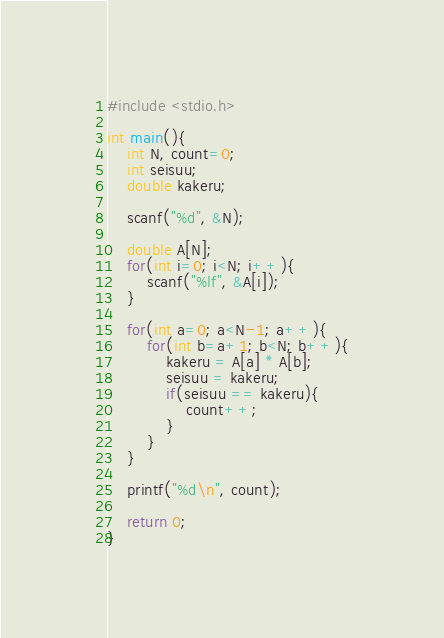<code> <loc_0><loc_0><loc_500><loc_500><_C_>#include <stdio.h>

int main(){
    int N, count=0;
    int seisuu;
    double kakeru;

    scanf("%d", &N);

    double A[N];
    for(int i=0; i<N; i++){
        scanf("%lf", &A[i]);
    }

    for(int a=0; a<N-1; a++){
        for(int b=a+1; b<N; b++){
            kakeru = A[a] * A[b];
            seisuu = kakeru;
            if(seisuu == kakeru){
                count++;
            }
        }
    }

    printf("%d\n", count);

    return 0;
}</code> 